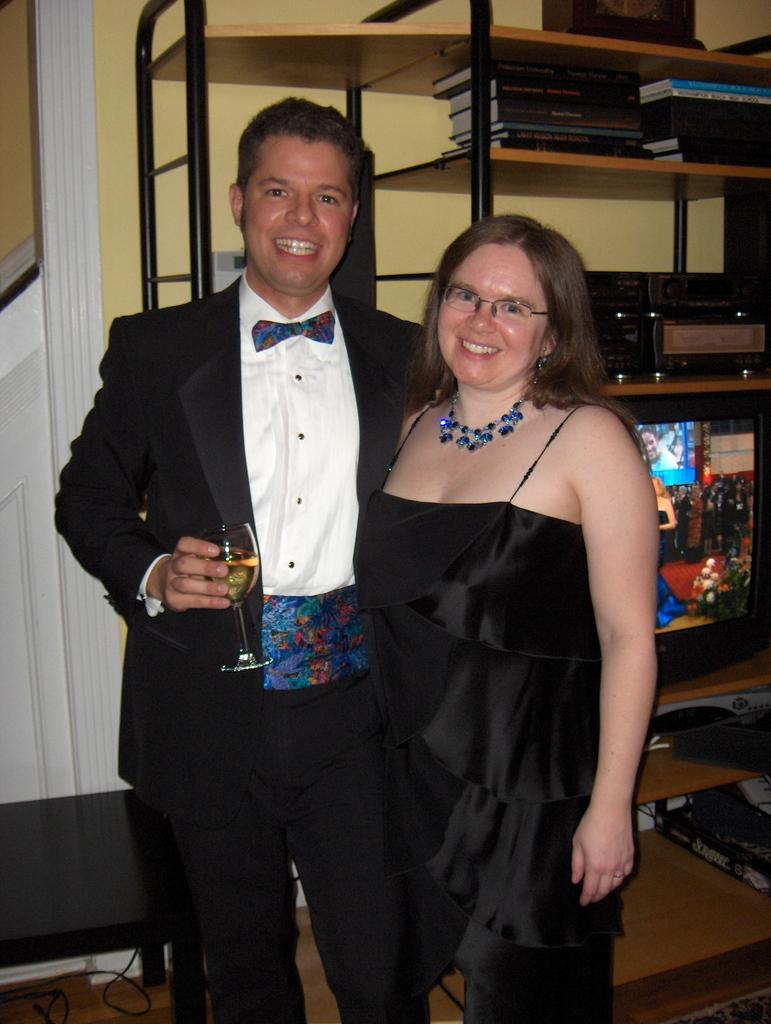How many people are in the image? There are two persons standing in the image. What is one person holding? One person is holding a glass. What can be seen in the background of the image? There are racks and books visible in the background of the image. What type of cup is hanging from the icicle in the image? There is no cup or icicle present in the image. How many bulbs are visible on the racks in the image? The provided facts do not mention any bulbs, so we cannot determine the number of bulbs visible on the racks. 